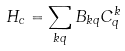Convert formula to latex. <formula><loc_0><loc_0><loc_500><loc_500>H _ { c } = \sum _ { k q } { B _ { k q } C ^ { k } _ { q } }</formula> 